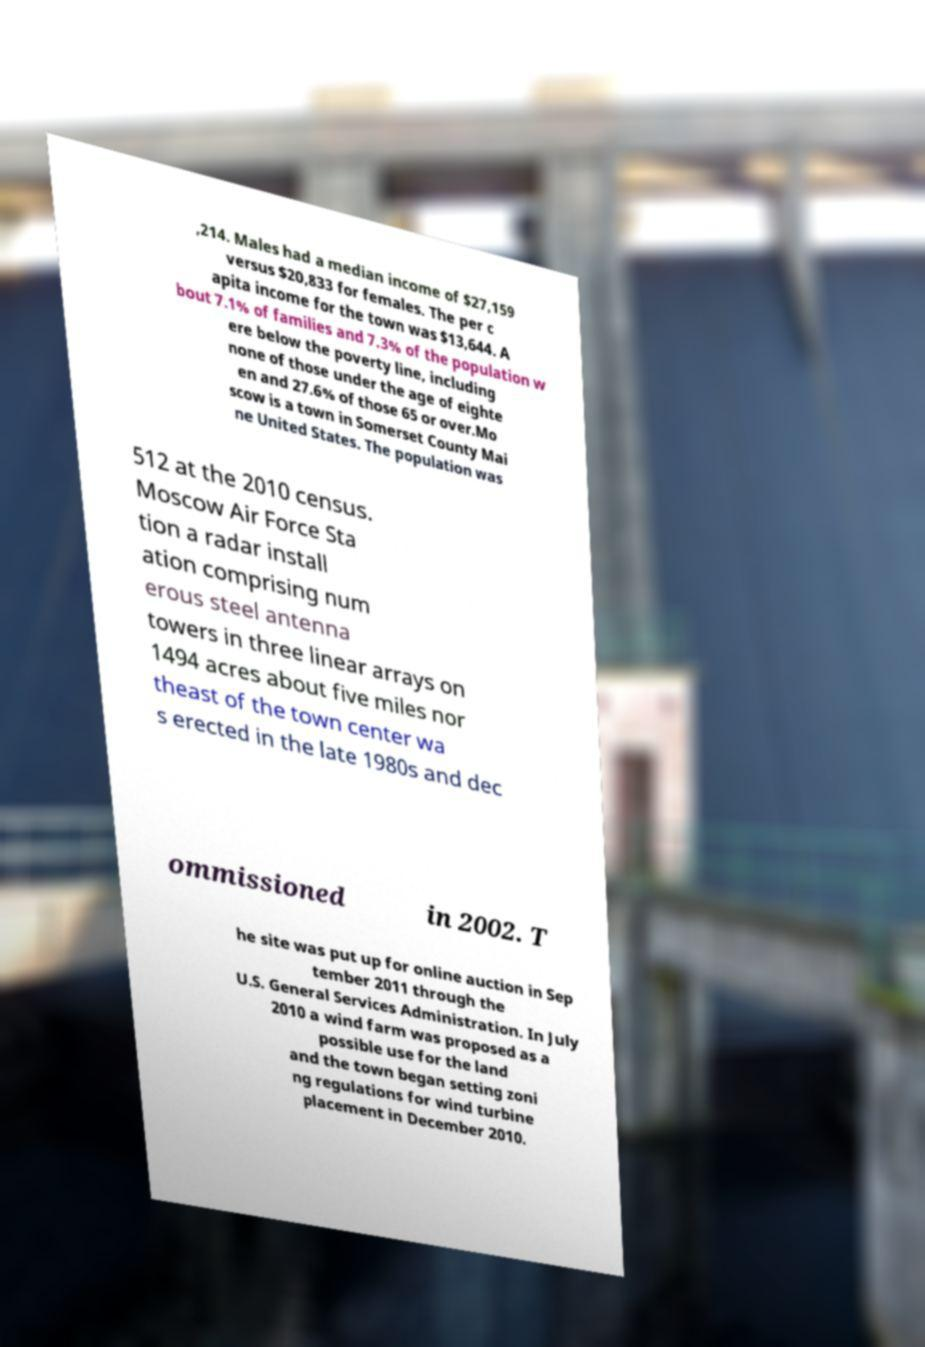Please read and relay the text visible in this image. What does it say? ,214. Males had a median income of $27,159 versus $20,833 for females. The per c apita income for the town was $13,644. A bout 7.1% of families and 7.3% of the population w ere below the poverty line, including none of those under the age of eighte en and 27.6% of those 65 or over.Mo scow is a town in Somerset County Mai ne United States. The population was 512 at the 2010 census. Moscow Air Force Sta tion a radar install ation comprising num erous steel antenna towers in three linear arrays on 1494 acres about five miles nor theast of the town center wa s erected in the late 1980s and dec ommissioned in 2002. T he site was put up for online auction in Sep tember 2011 through the U.S. General Services Administration. In July 2010 a wind farm was proposed as a possible use for the land and the town began setting zoni ng regulations for wind turbine placement in December 2010. 